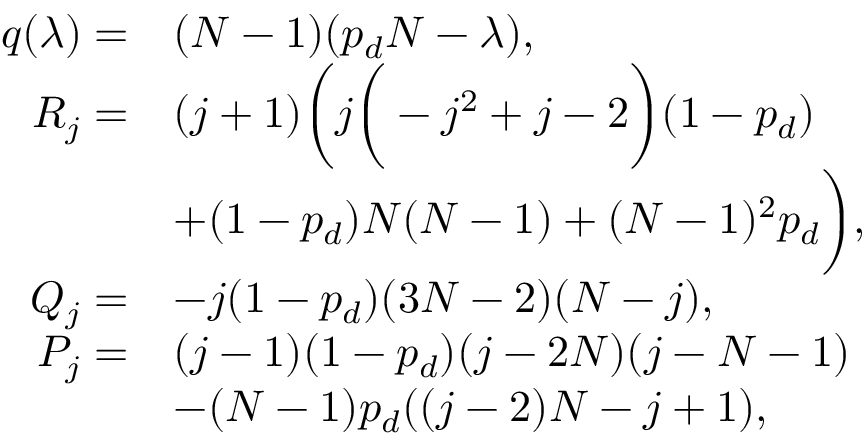Convert formula to latex. <formula><loc_0><loc_0><loc_500><loc_500>\begin{array} { r l } { q ( \lambda ) = } & { ( N - 1 ) ( p _ { d } N - \lambda ) , } \\ { R _ { j } = } & { ( j + 1 ) \left ( j \left ( - j ^ { 2 } + j - 2 \right ) ( 1 - p _ { d } ) } \\ & { + ( 1 - p _ { d } ) N ( N - 1 ) + ( N - 1 ) ^ { 2 } p _ { d } \right ) , } \\ { Q _ { j } = } & { - j ( 1 - p _ { d } ) ( 3 N - 2 ) ( N - j ) , } \\ { P _ { j } = } & { ( j - 1 ) ( 1 - p _ { d } ) ( j - 2 N ) ( j - N - 1 ) } \\ & { - ( N - 1 ) p _ { d } ( ( j - 2 ) N - j + 1 ) , } \end{array}</formula> 